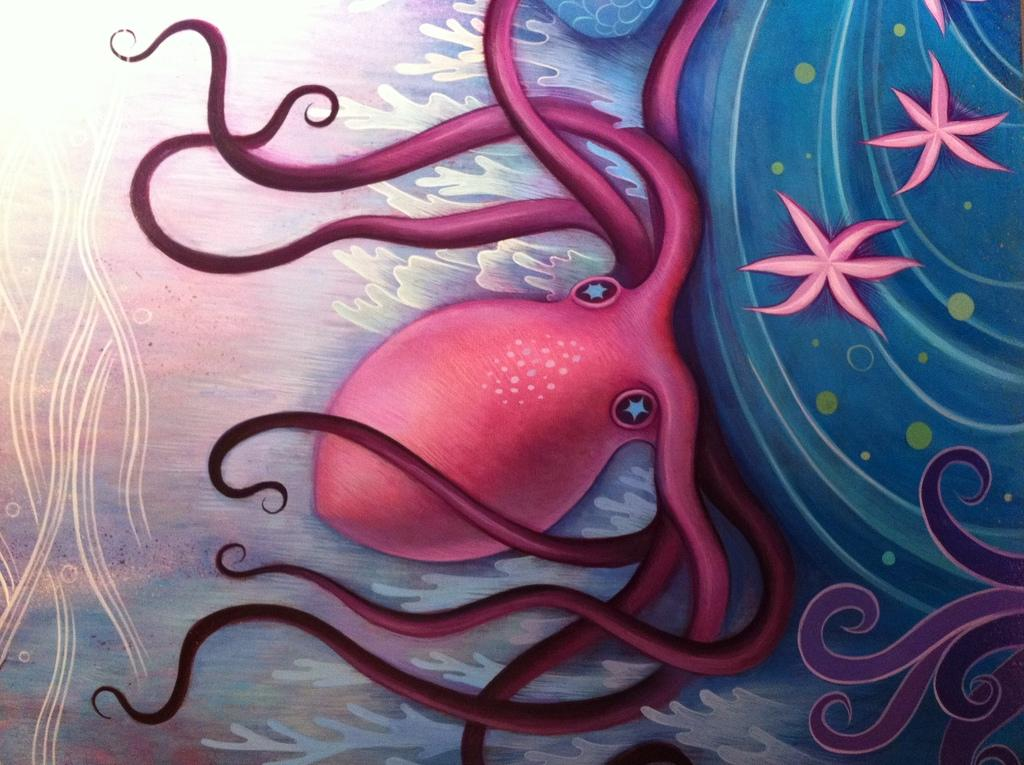What type of artwork is shown in the image? The image is a painting. What sea creatures are depicted in the painting? The painting depicts an octopus and a starfish. What is the name of the person who painted the image? The provided facts do not mention the name of the artist who created the painting. Does the octopus in the painting own any property? The octopus in the painting is a fictional representation and does not own any property. 